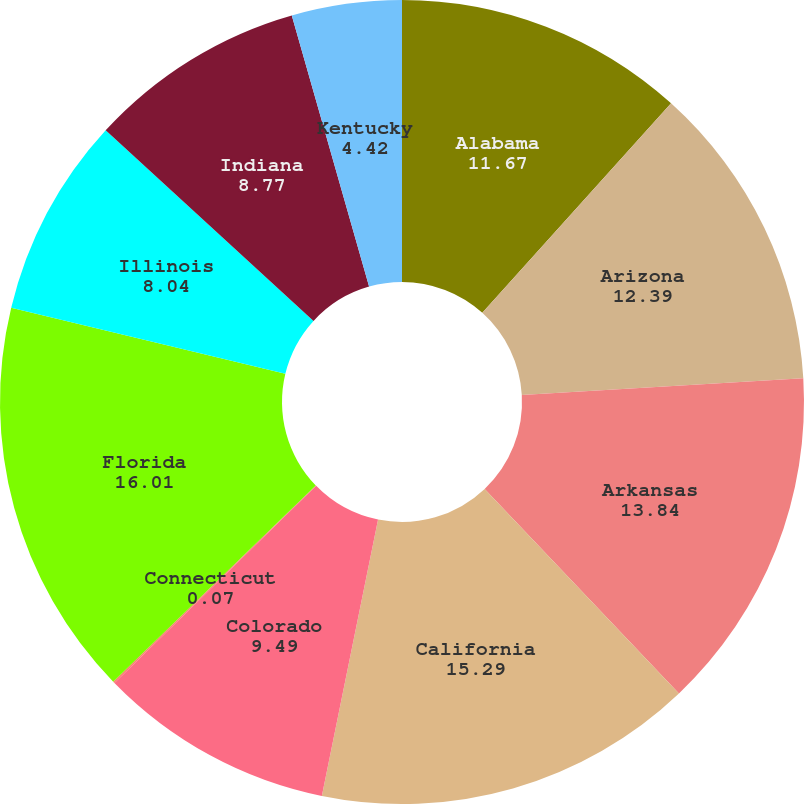Convert chart to OTSL. <chart><loc_0><loc_0><loc_500><loc_500><pie_chart><fcel>Alabama<fcel>Arizona<fcel>Arkansas<fcel>California<fcel>Colorado<fcel>Connecticut<fcel>Florida<fcel>Illinois<fcel>Indiana<fcel>Kentucky<nl><fcel>11.67%<fcel>12.39%<fcel>13.84%<fcel>15.29%<fcel>9.49%<fcel>0.07%<fcel>16.01%<fcel>8.04%<fcel>8.77%<fcel>4.42%<nl></chart> 